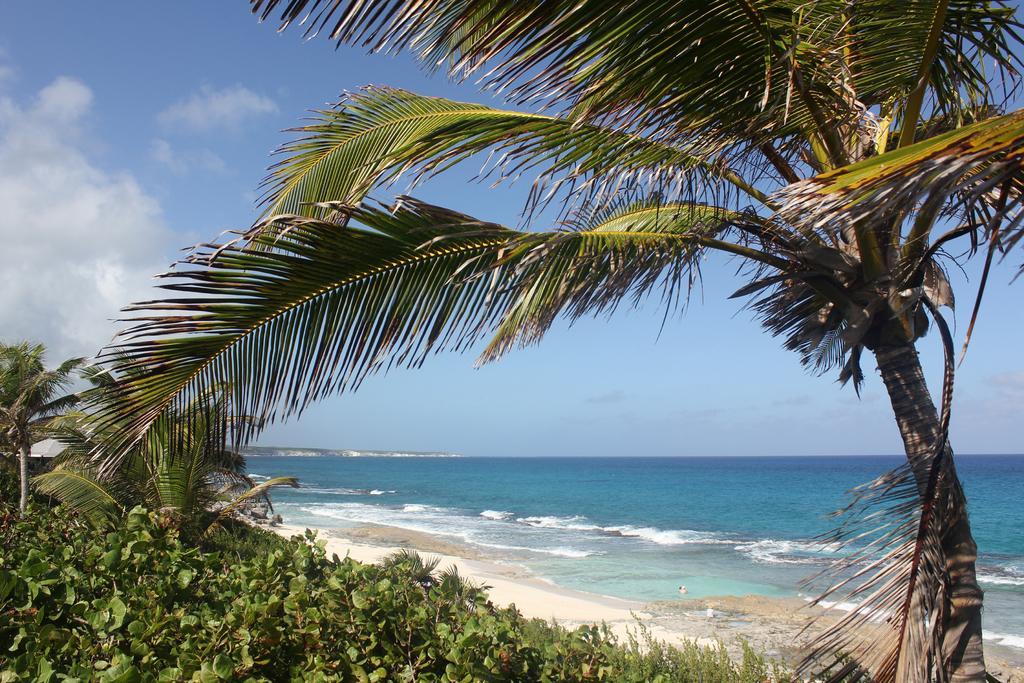How would you summarize this image in a sentence or two? In this image I can see a tree , few plants, the sand , the water and the sky and I can see a tent which is ash in color. 